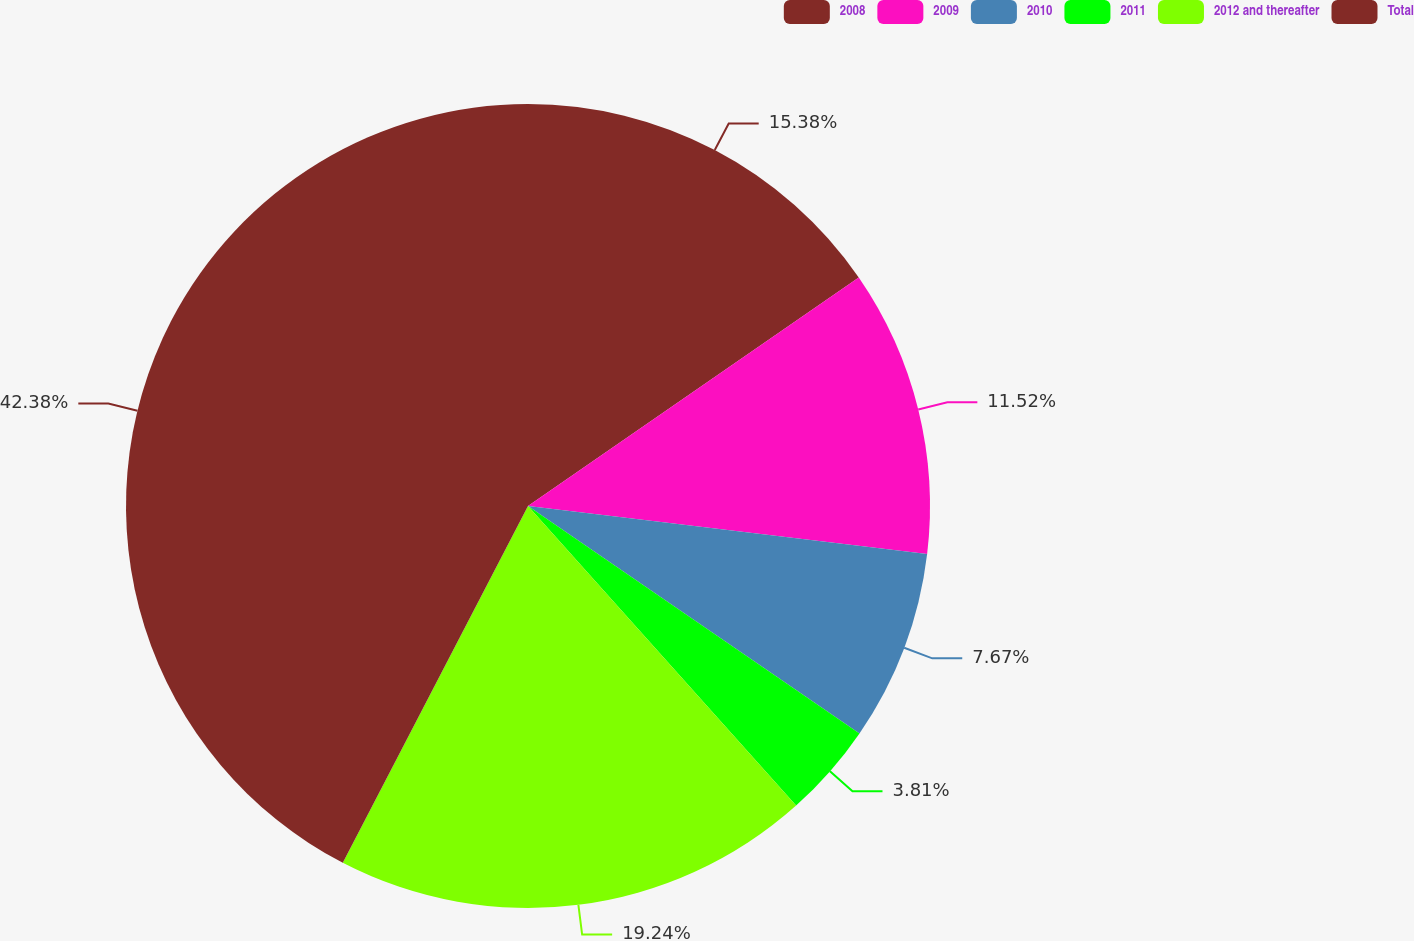Convert chart to OTSL. <chart><loc_0><loc_0><loc_500><loc_500><pie_chart><fcel>2008<fcel>2009<fcel>2010<fcel>2011<fcel>2012 and thereafter<fcel>Total<nl><fcel>15.38%<fcel>11.52%<fcel>7.67%<fcel>3.81%<fcel>19.24%<fcel>42.38%<nl></chart> 